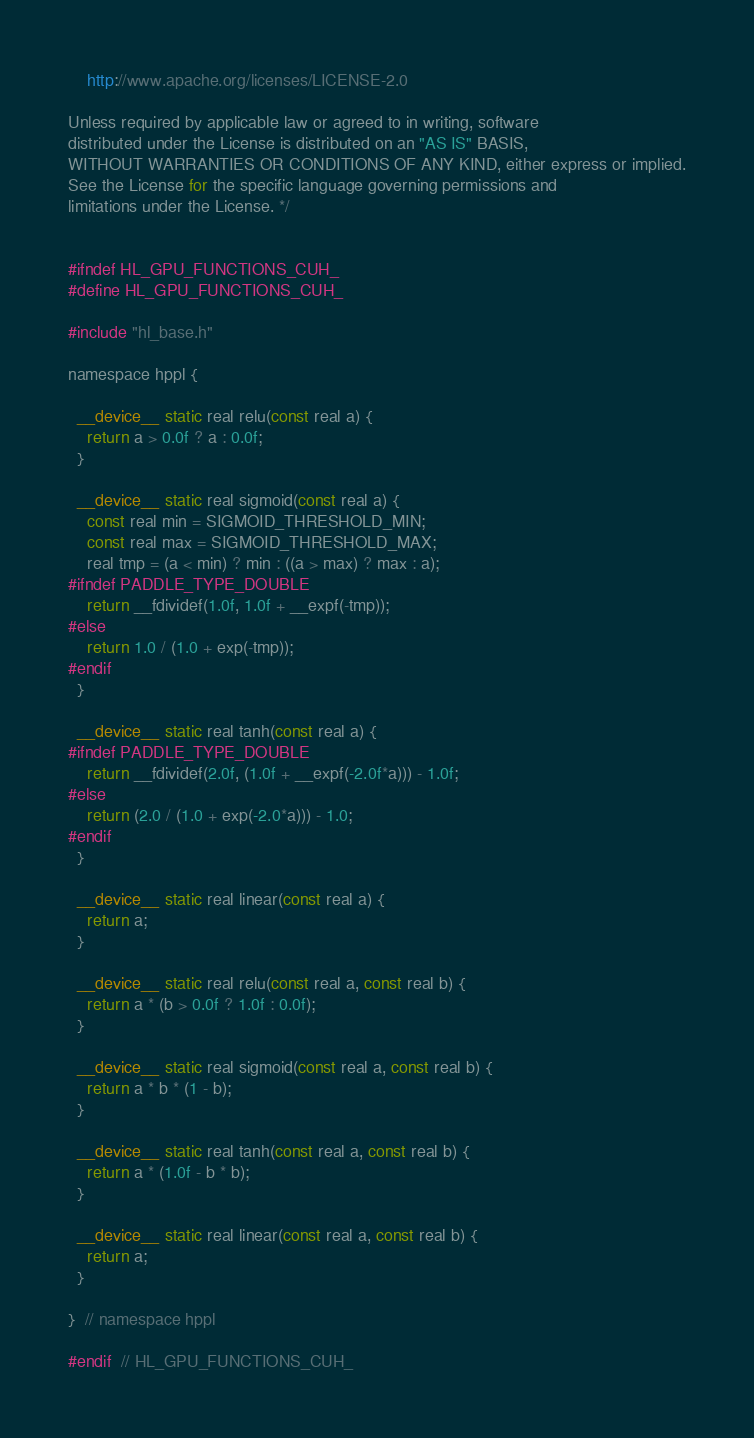Convert code to text. <code><loc_0><loc_0><loc_500><loc_500><_Cuda_>
    http://www.apache.org/licenses/LICENSE-2.0

Unless required by applicable law or agreed to in writing, software
distributed under the License is distributed on an "AS IS" BASIS,
WITHOUT WARRANTIES OR CONDITIONS OF ANY KIND, either express or implied.
See the License for the specific language governing permissions and
limitations under the License. */


#ifndef HL_GPU_FUNCTIONS_CUH_
#define HL_GPU_FUNCTIONS_CUH_

#include "hl_base.h"

namespace hppl {

  __device__ static real relu(const real a) {
    return a > 0.0f ? a : 0.0f;
  }

  __device__ static real sigmoid(const real a) {
    const real min = SIGMOID_THRESHOLD_MIN;
    const real max = SIGMOID_THRESHOLD_MAX;
    real tmp = (a < min) ? min : ((a > max) ? max : a);
#ifndef PADDLE_TYPE_DOUBLE
    return __fdividef(1.0f, 1.0f + __expf(-tmp));
#else
    return 1.0 / (1.0 + exp(-tmp));
#endif
  }

  __device__ static real tanh(const real a) {
#ifndef PADDLE_TYPE_DOUBLE
    return __fdividef(2.0f, (1.0f + __expf(-2.0f*a))) - 1.0f;
#else
    return (2.0 / (1.0 + exp(-2.0*a))) - 1.0;
#endif
  }

  __device__ static real linear(const real a) {
    return a;
  }

  __device__ static real relu(const real a, const real b) {
    return a * (b > 0.0f ? 1.0f : 0.0f);
  }

  __device__ static real sigmoid(const real a, const real b) {
    return a * b * (1 - b);
  }

  __device__ static real tanh(const real a, const real b) {
    return a * (1.0f - b * b);
  }

  __device__ static real linear(const real a, const real b) {
    return a;
  }

}  // namespace hppl

#endif  // HL_GPU_FUNCTIONS_CUH_
</code> 